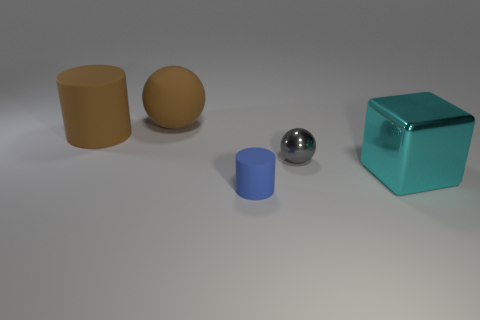There is a ball that is the same color as the big rubber cylinder; what is its material?
Ensure brevity in your answer.  Rubber. Do the cylinder behind the big cyan block and the matte sphere have the same color?
Your answer should be compact. Yes. There is a big sphere; is its color the same as the cylinder behind the metal ball?
Ensure brevity in your answer.  Yes. What is the size of the gray ball?
Give a very brief answer. Small. How many cylinders are in front of the big object that is to the right of the small blue rubber thing?
Provide a succinct answer. 1. What shape is the thing that is both in front of the tiny gray metallic sphere and left of the small metal object?
Make the answer very short. Cylinder. How many small matte cylinders have the same color as the shiny cube?
Give a very brief answer. 0. Is there a large cyan thing that is to the left of the matte thing that is in front of the metallic cube on the right side of the tiny ball?
Provide a short and direct response. No. There is a object that is both in front of the small gray metal ball and on the left side of the cyan shiny thing; what size is it?
Your response must be concise. Small. What number of objects have the same material as the big ball?
Make the answer very short. 2. 